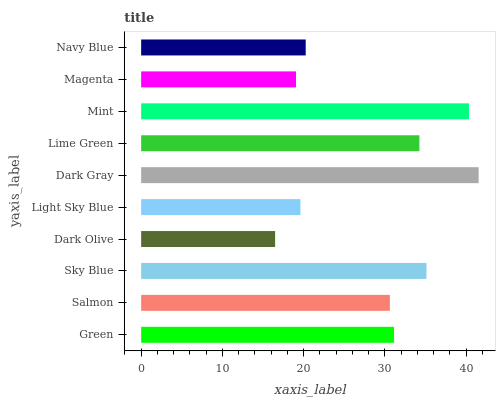Is Dark Olive the minimum?
Answer yes or no. Yes. Is Dark Gray the maximum?
Answer yes or no. Yes. Is Salmon the minimum?
Answer yes or no. No. Is Salmon the maximum?
Answer yes or no. No. Is Green greater than Salmon?
Answer yes or no. Yes. Is Salmon less than Green?
Answer yes or no. Yes. Is Salmon greater than Green?
Answer yes or no. No. Is Green less than Salmon?
Answer yes or no. No. Is Green the high median?
Answer yes or no. Yes. Is Salmon the low median?
Answer yes or no. Yes. Is Dark Olive the high median?
Answer yes or no. No. Is Dark Olive the low median?
Answer yes or no. No. 